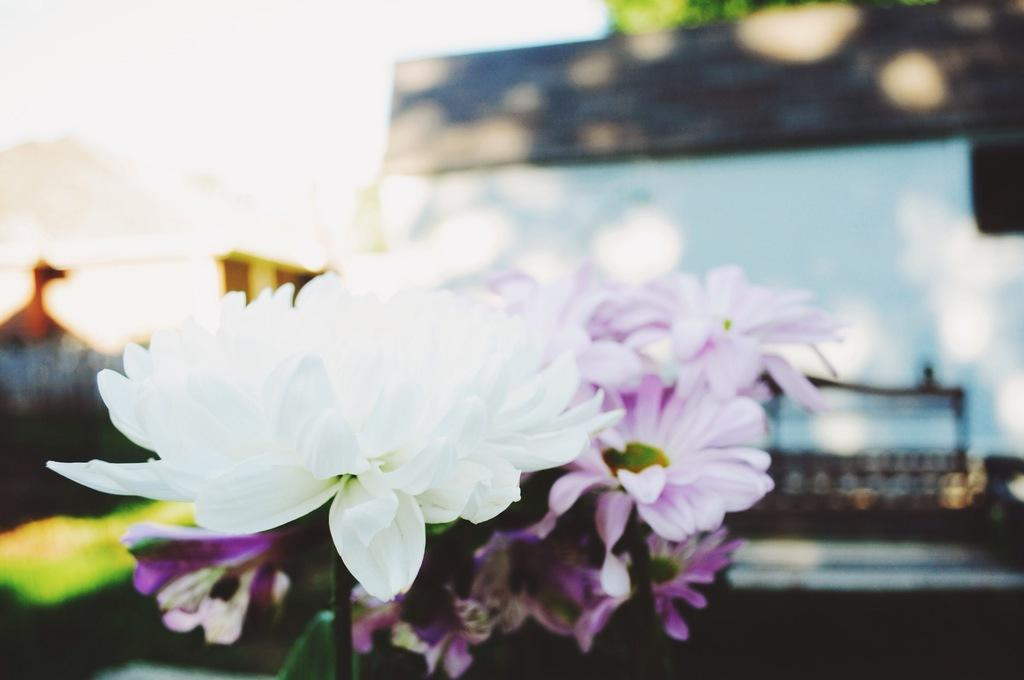What type of plants can be seen in the image? There are flowers in the image. What type of structure is present in the image? There is a building in the image. Can you describe the background of the image? The background of the image is blurred. What type of holiday is being celebrated in the image? There is no indication of a holiday being celebrated in the image. What type of desk is visible in the image? There is no desk present in the image. 